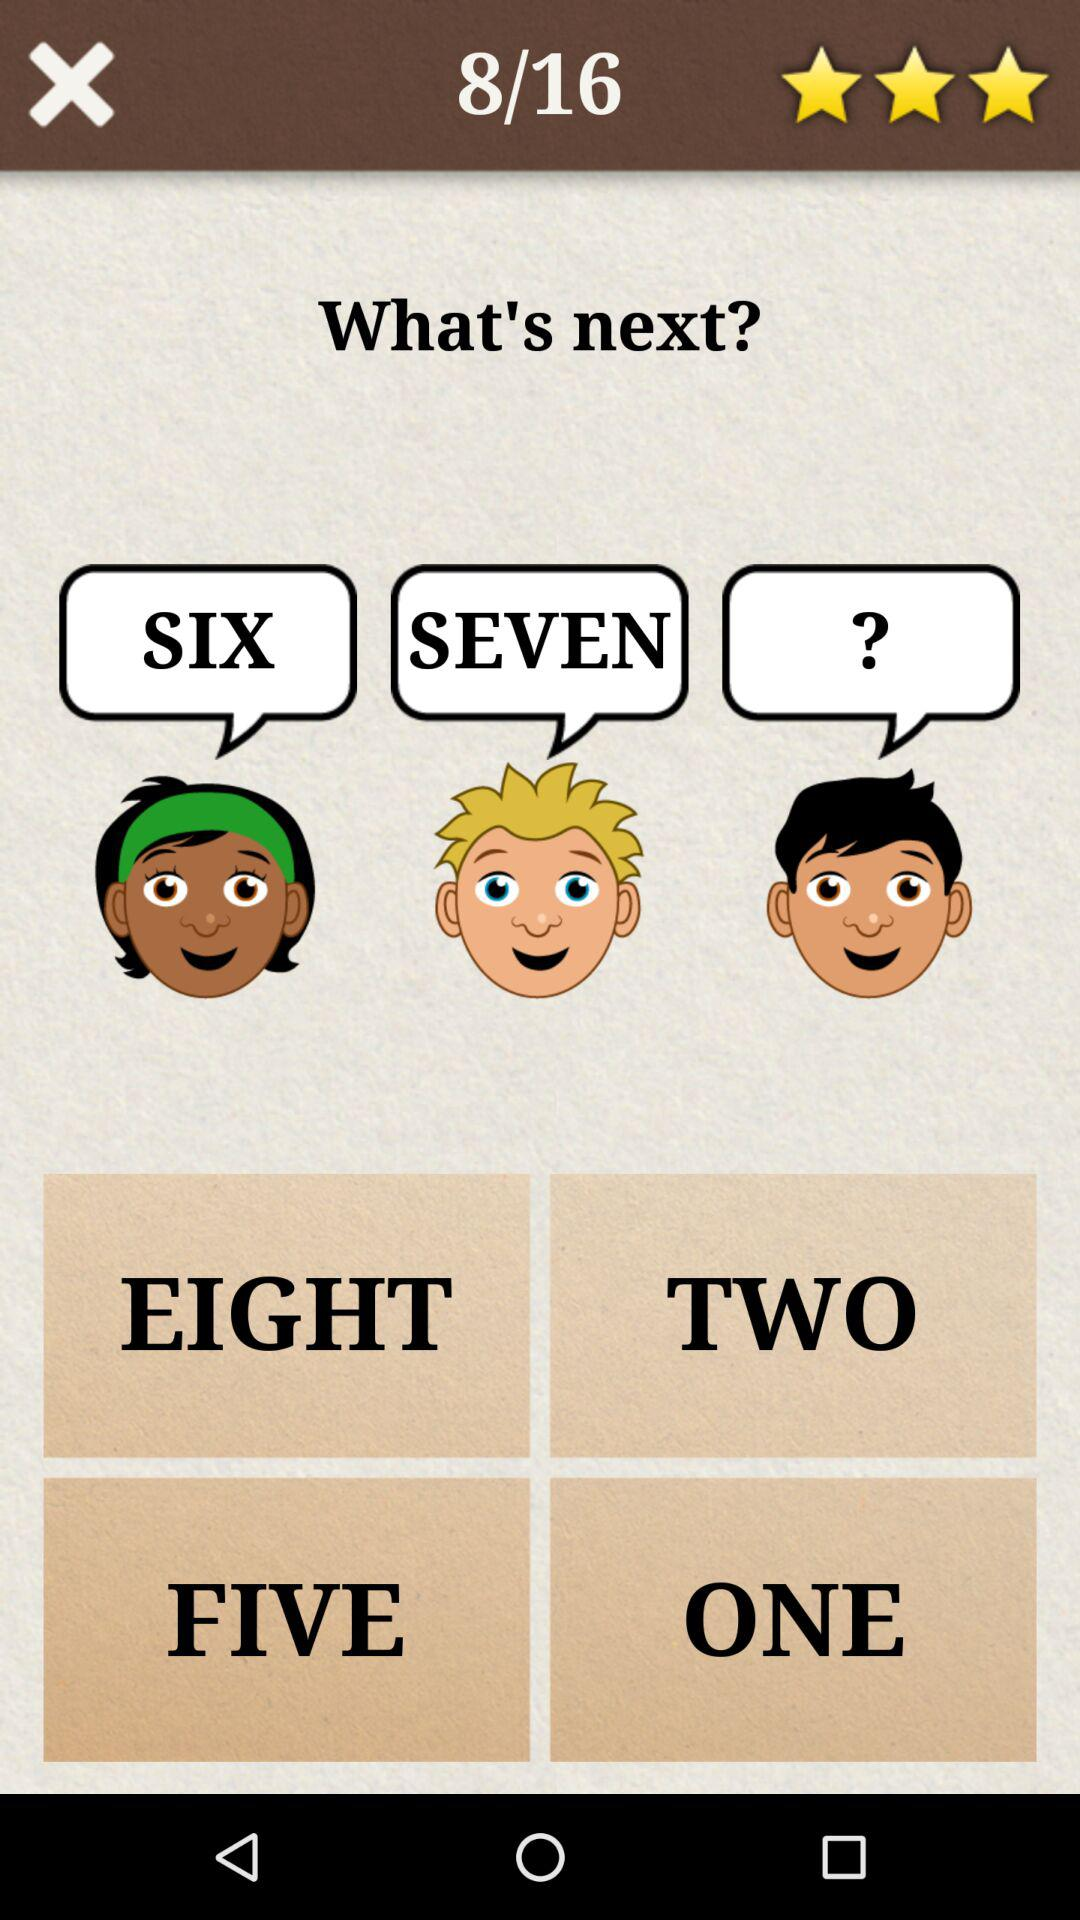Which question am I at? You are at question number 8. 